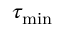Convert formula to latex. <formula><loc_0><loc_0><loc_500><loc_500>\tau _ { \min }</formula> 